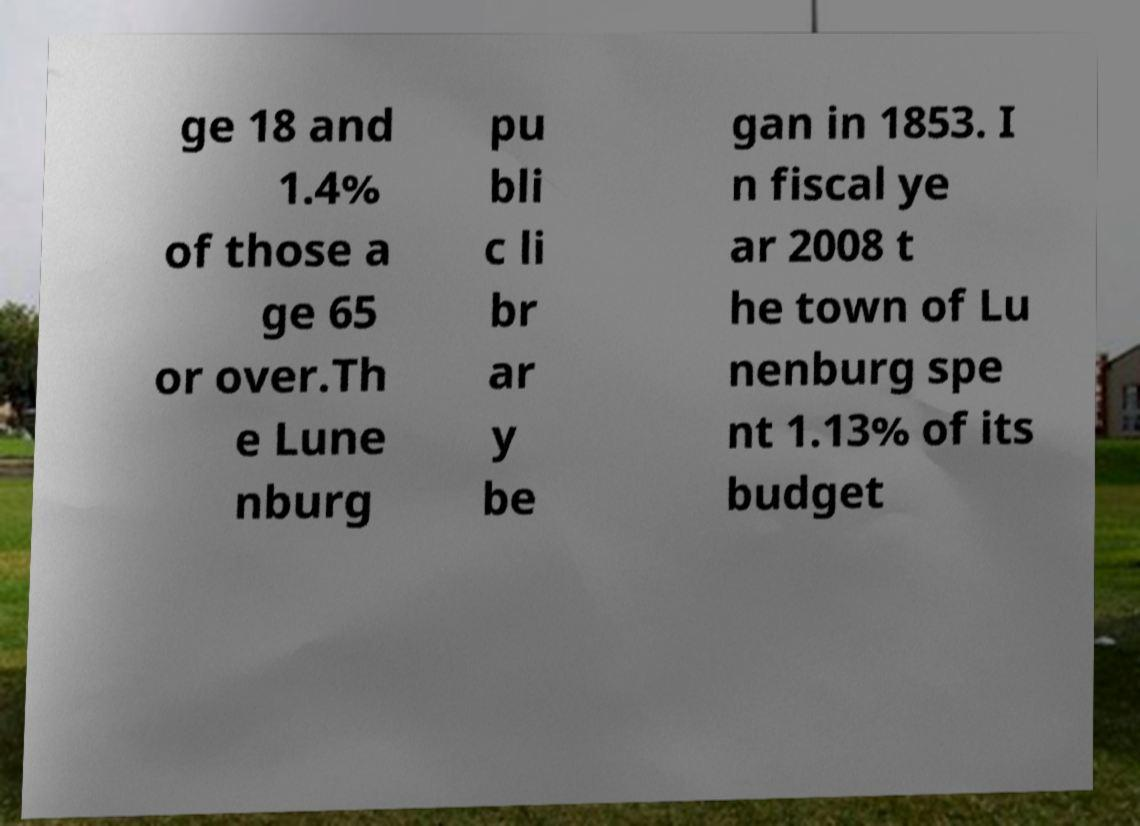I need the written content from this picture converted into text. Can you do that? ge 18 and 1.4% of those a ge 65 or over.Th e Lune nburg pu bli c li br ar y be gan in 1853. I n fiscal ye ar 2008 t he town of Lu nenburg spe nt 1.13% of its budget 